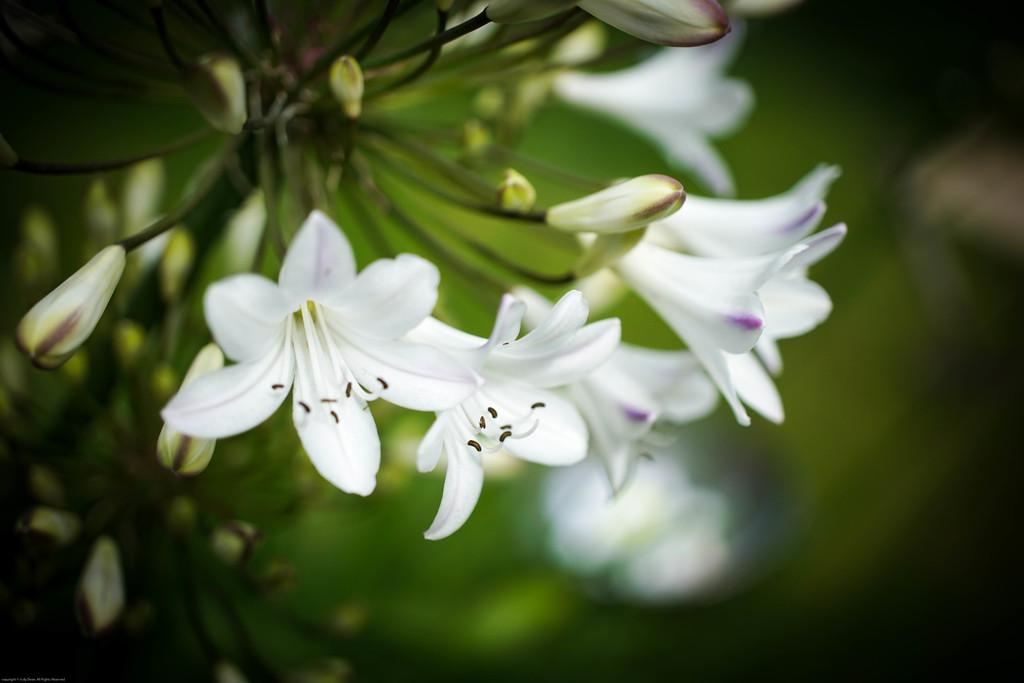What type of plants are in the image? There are flowers in the image. What color are the flowers? The flowers are white in color. Can you describe any stage of growth for the flowers in the image? Yes, there are buds visible in the image. What type of zipper can be seen on the flowers in the image? There is no zipper present on the flowers in the image. Can you describe the behavior of the duck in the image? There is no duck present in the image. 